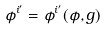<formula> <loc_0><loc_0><loc_500><loc_500>\phi ^ { i ^ { \prime } } = \phi ^ { i ^ { \prime } } ( \phi , g )</formula> 